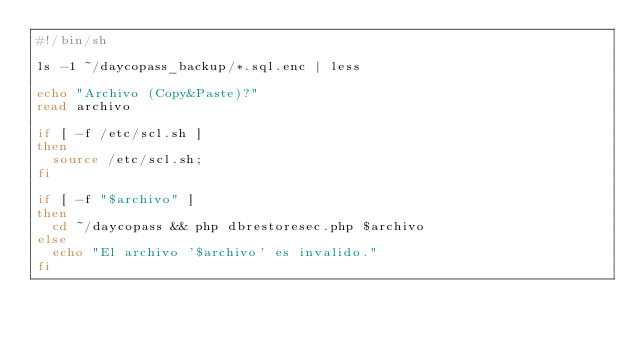<code> <loc_0><loc_0><loc_500><loc_500><_Bash_>#!/bin/sh

ls -1 ~/daycopass_backup/*.sql.enc | less

echo "Archivo (Copy&Paste)?"
read archivo

if [ -f /etc/scl.sh ]
then
  source /etc/scl.sh;
fi

if [ -f "$archivo" ]
then
	cd ~/daycopass && php dbrestoresec.php $archivo
else
	echo "El archivo '$archivo' es invalido."
fi
</code> 